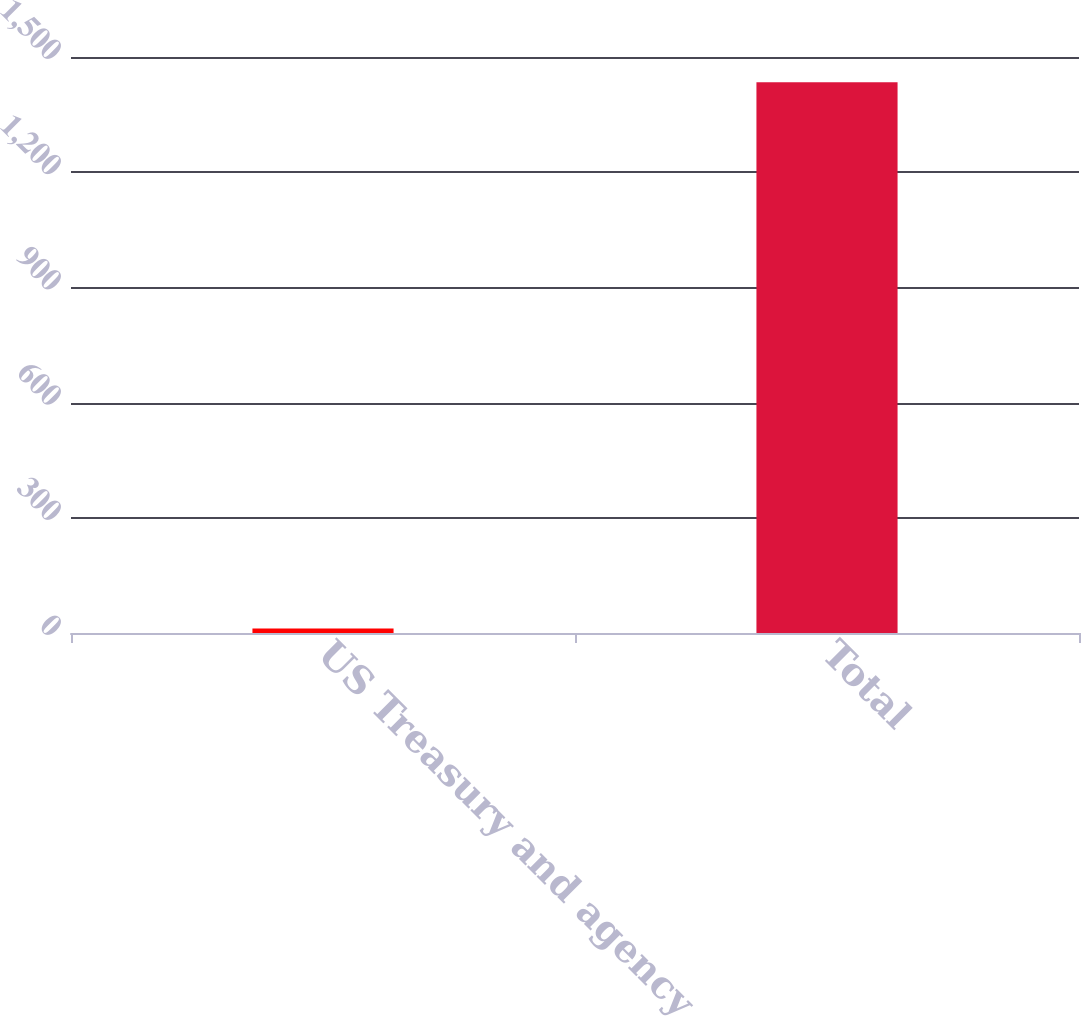<chart> <loc_0><loc_0><loc_500><loc_500><bar_chart><fcel>US Treasury and agency<fcel>Total<nl><fcel>12<fcel>1434<nl></chart> 